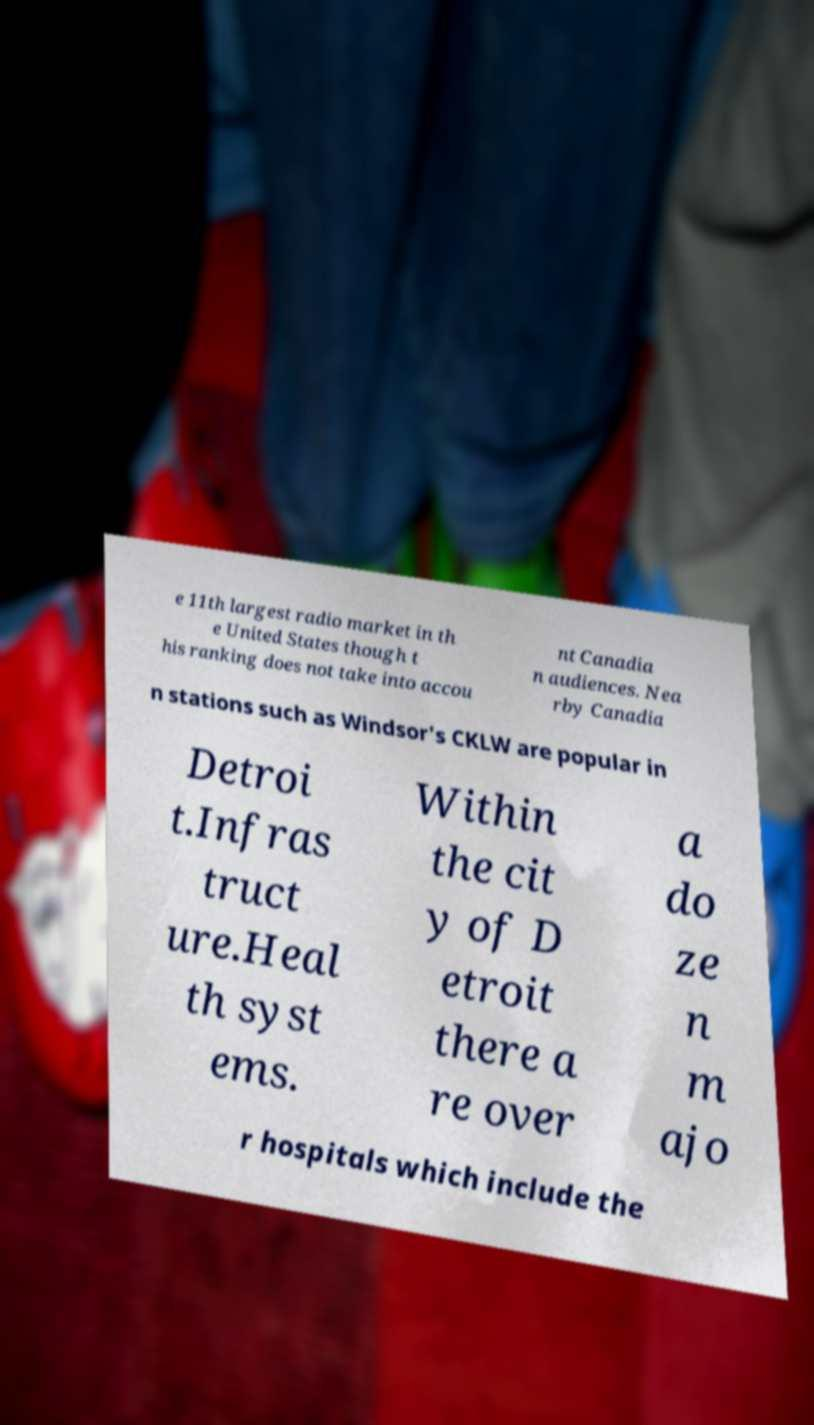There's text embedded in this image that I need extracted. Can you transcribe it verbatim? e 11th largest radio market in th e United States though t his ranking does not take into accou nt Canadia n audiences. Nea rby Canadia n stations such as Windsor's CKLW are popular in Detroi t.Infras truct ure.Heal th syst ems. Within the cit y of D etroit there a re over a do ze n m ajo r hospitals which include the 